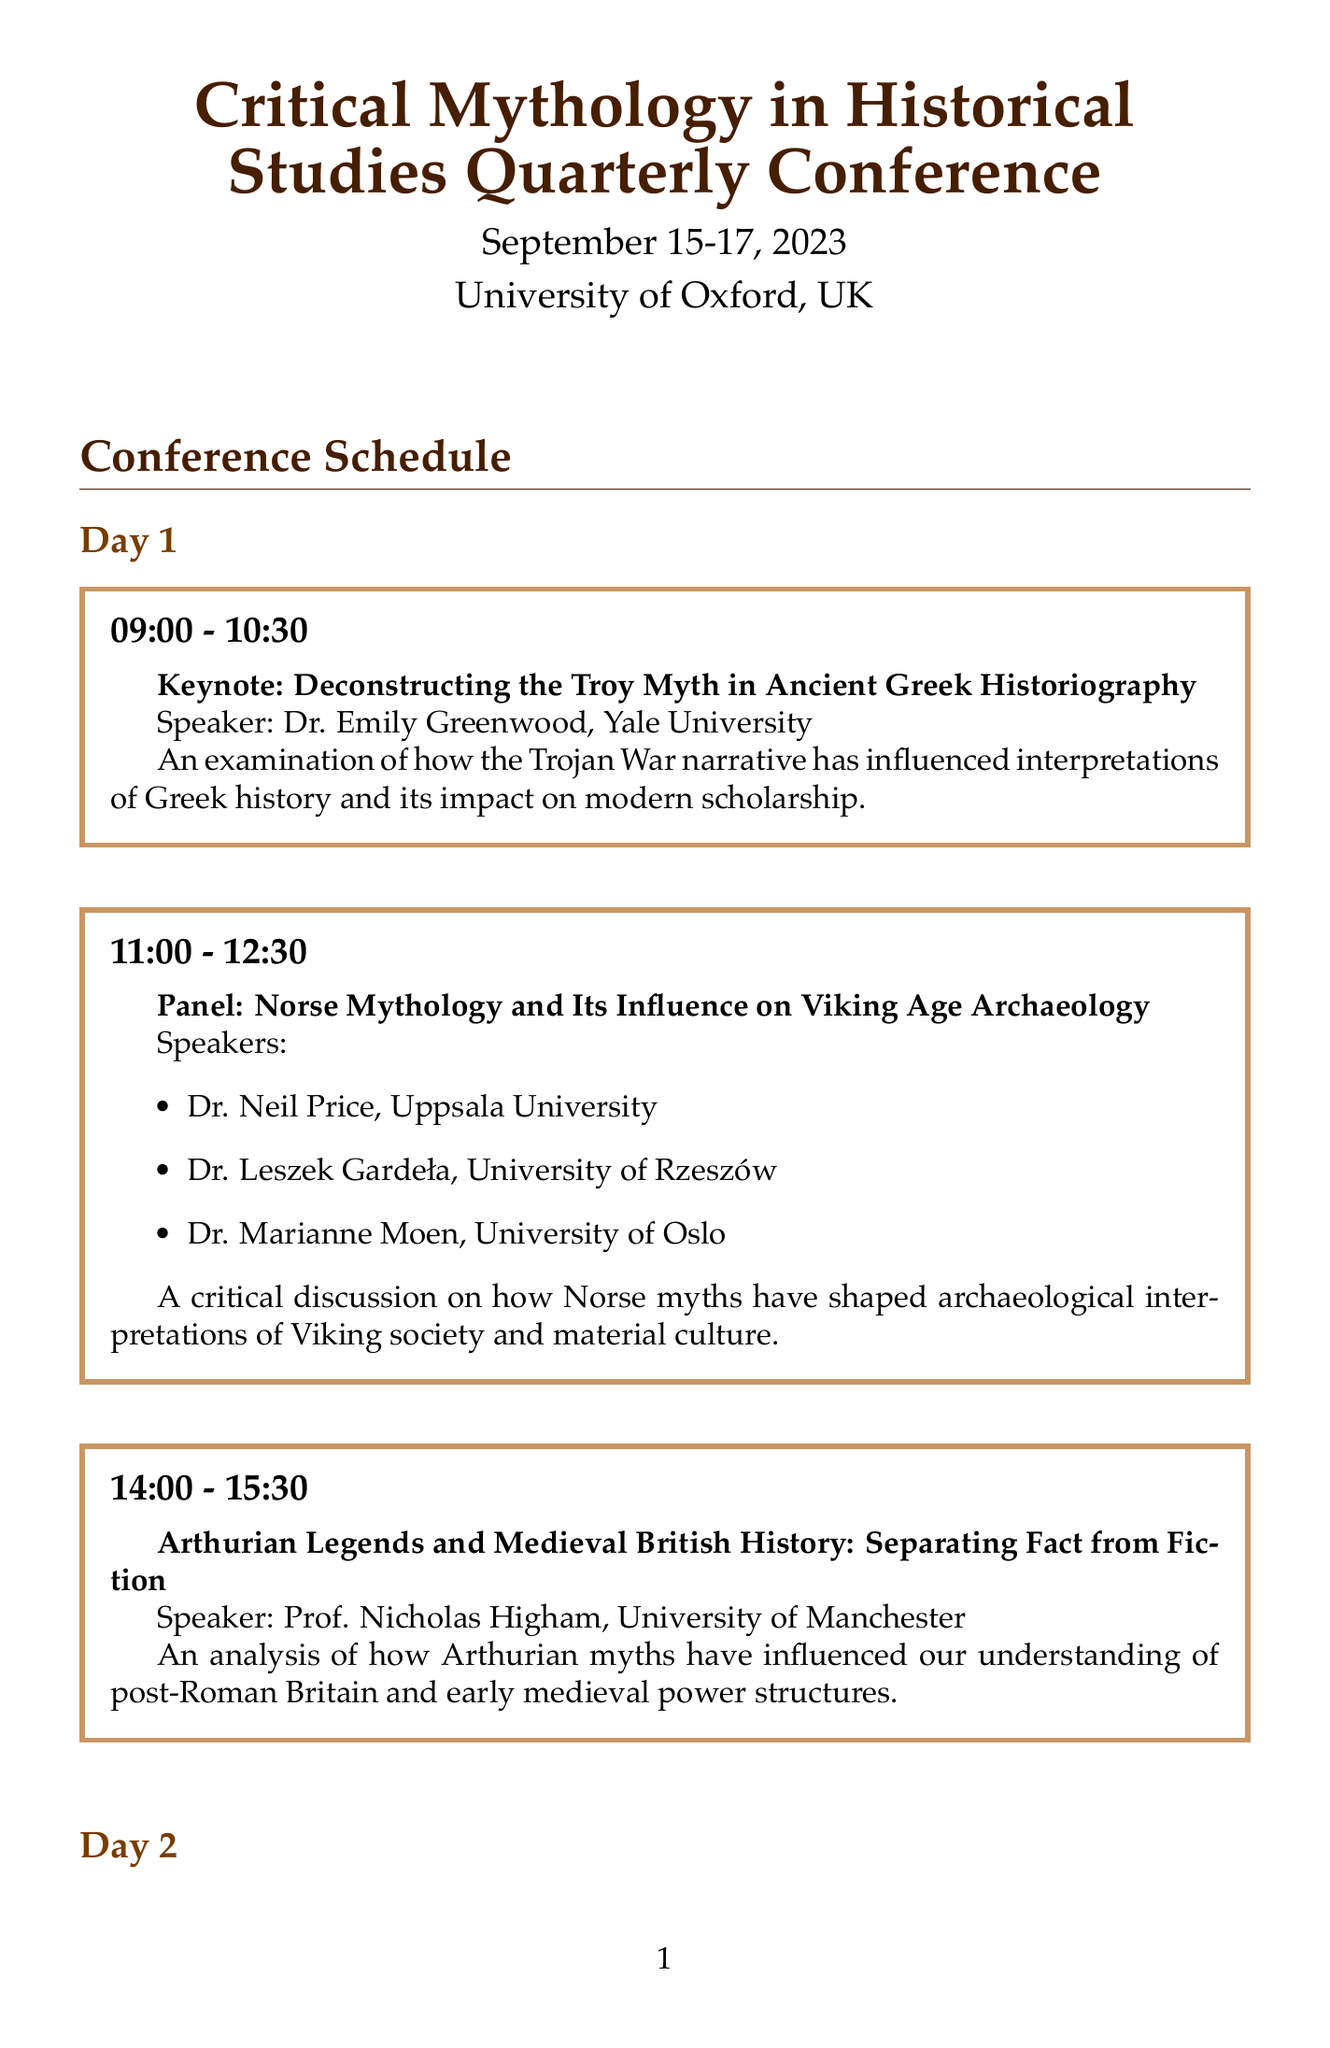What is the name of the conference? The name of the conference is mentioned at the top of the document as "Critical Mythology in Historical Studies Quarterly Conference."
Answer: Critical Mythology in Historical Studies Quarterly Conference Who is the keynote speaker for Day 1? The document lists Dr. Emily Greenwood as the keynote speaker for Day 1, from Yale University.
Answer: Dr. Emily Greenwood What time does Day 2's workshop start? The schedule specifies that the workshop on Day 2 begins at 11:00.
Answer: 11:00 What is the primary focus of the presentation by Dr. Anthony D. Smith? The description states that this presentation examines national founding myths and their impact on historical narratives and political ideologies.
Answer: Founding myths in nation-building How many speakers are on the panel discussing the impact of religious myths? The document details that there are three speakers participating in the panel on this topic.
Answer: Three speakers What is the theme of Day 3's closing keynote? The closing keynote topic is mentioned as "The Future of Critical Mythology in Historical Studies."
Answer: The Future of Critical Mythology in Historical Studies Which university does Prof. Richard Buxton represent? The document indicates that Prof. Richard Buxton is from the University of Bristol.
Answer: University of Bristol What is the time allocated for presentations on Day 3? Each presentation on Day 3 is allocated 1.5 hours, shown by the time slots presented.
Answer: 1.5 hours 